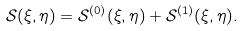<formula> <loc_0><loc_0><loc_500><loc_500>\mathcal { S } ( \xi , \eta ) = \mathcal { S } ^ { ( 0 ) } ( \xi , \eta ) + \mathcal { S } ^ { ( 1 ) } ( \xi , \eta ) .</formula> 